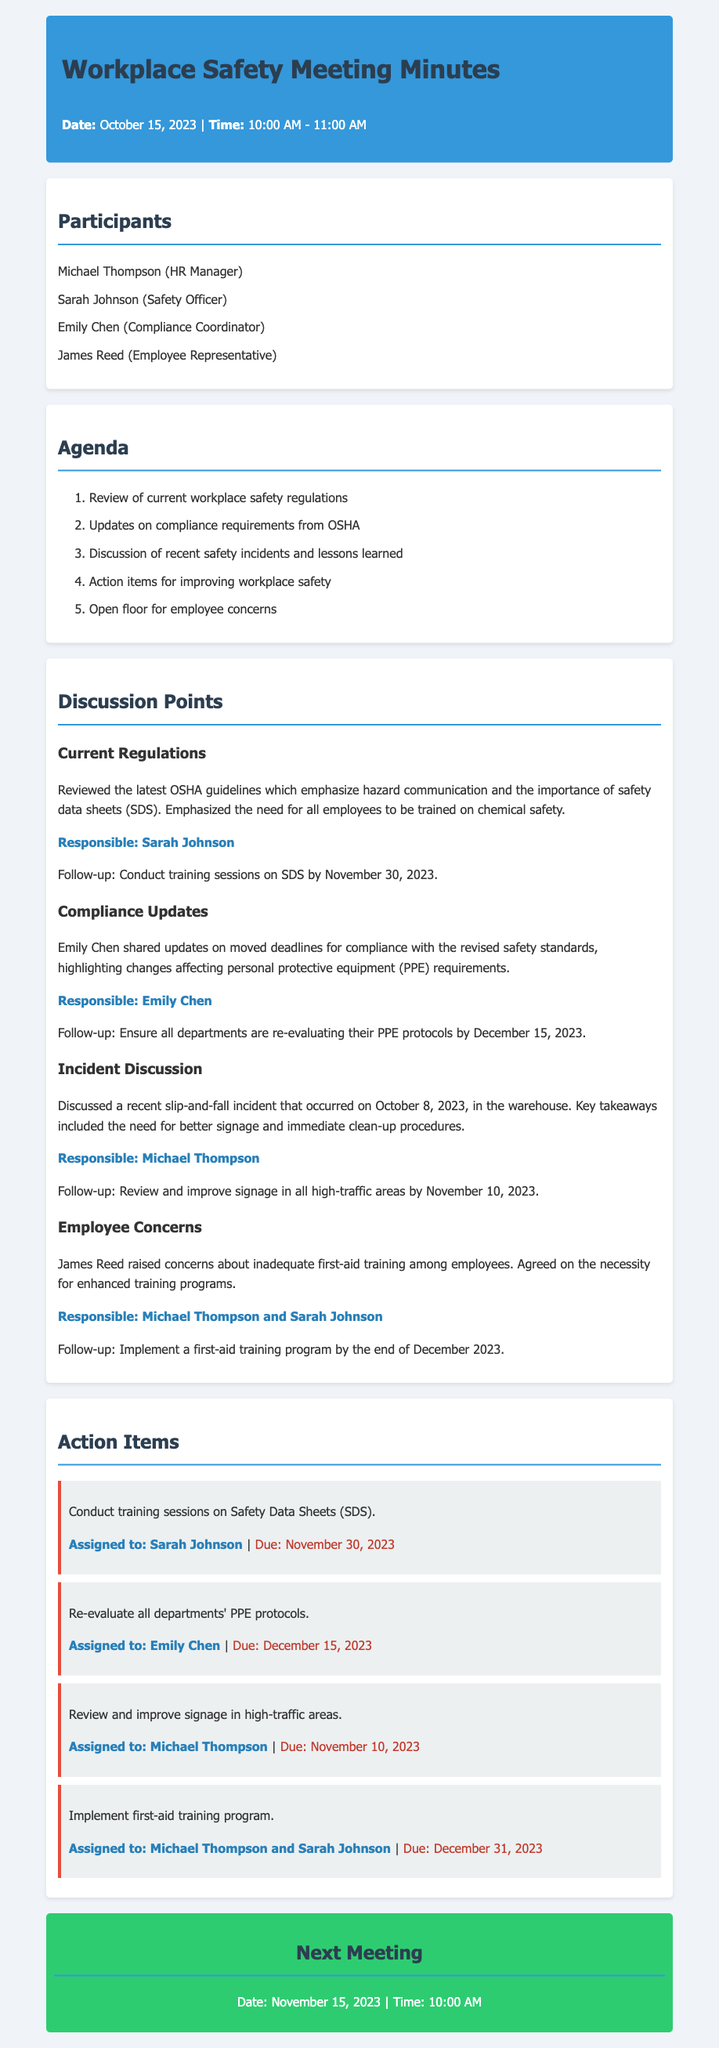What date was the meeting held? The date of the meeting is listed at the top of the document under the header section.
Answer: October 15, 2023 Who is responsible for conducting training sessions on Safety Data Sheets? The document specifies who is responsible for each action item, including training sessions.
Answer: Sarah Johnson What is the due date for reviewing and improving signage in high-traffic areas? The due date for this action item is mentioned alongside the responsible party.
Answer: November 10, 2023 What incident was discussed during the meeting? The document highlights specific incidents that were addressed in the discussion points section.
Answer: Slip-and-fall incident When is the next meeting scheduled? The next meeting information is provided in a dedicated section at the end of the document.
Answer: November 15, 2023 Which concern was raised by James Reed? The document notes employee concerns brought up during the meeting.
Answer: Inadequate first-aid training How many participants were in the meeting? The total number of participants can be counted from the list provided in the document.
Answer: Four What are the overall themes covered in the meeting agenda? The agenda outlines the main topics that were discussed during the meeting.
Answer: Workplace safety regulations, compliance updates, safety incidents, and employee concerns 